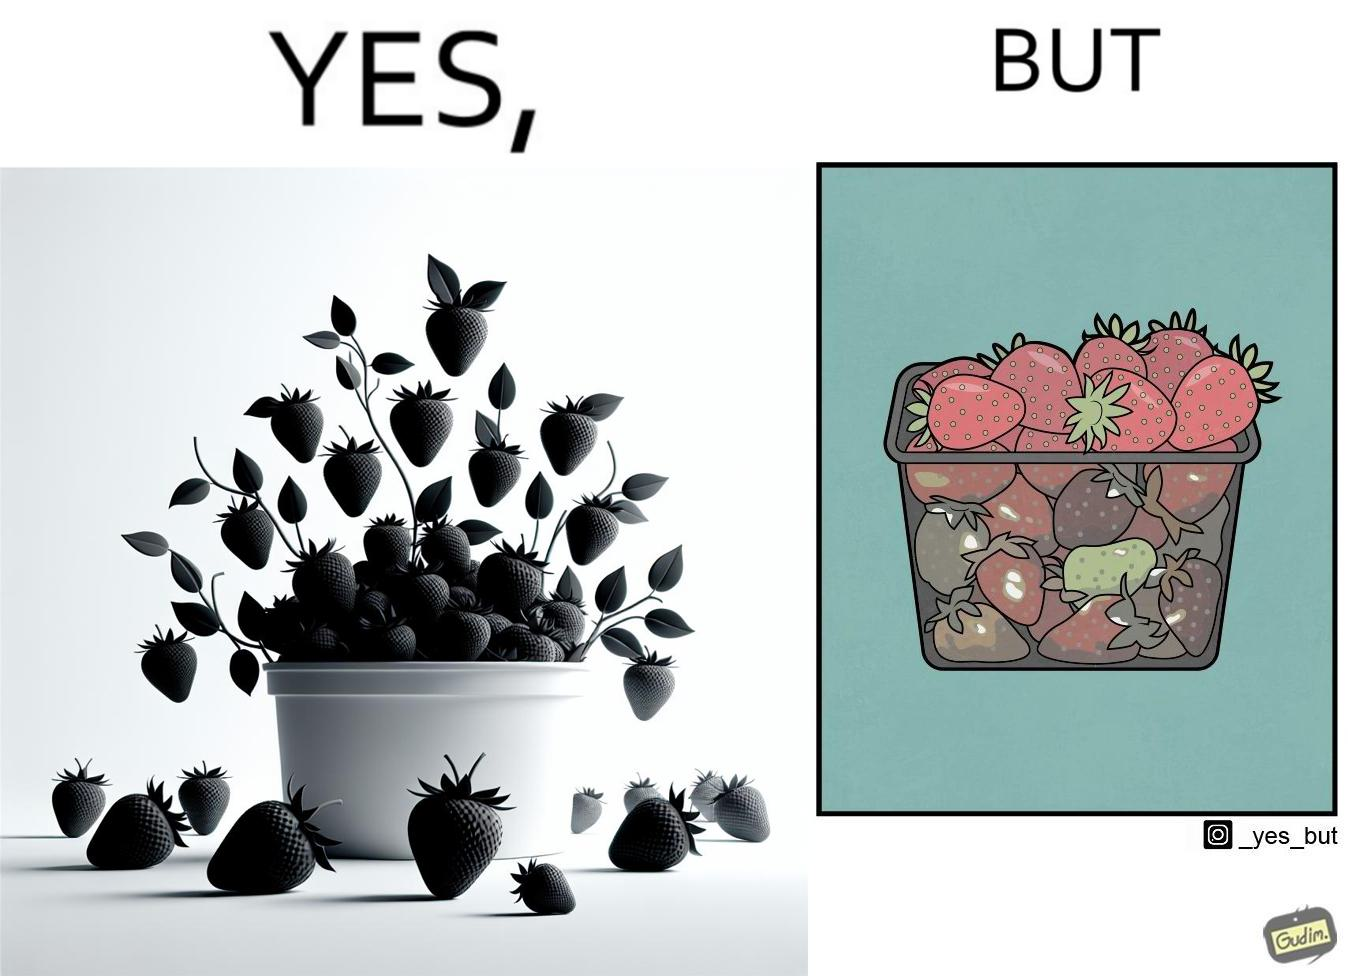Would you classify this image as satirical? Yes, this image is satirical. 